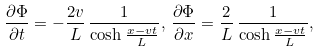Convert formula to latex. <formula><loc_0><loc_0><loc_500><loc_500>\frac { \partial \Phi } { \partial t } = - \frac { 2 v } { L } \, \frac { 1 } { \cosh { \frac { x - v t } { L } } } , \, \frac { \partial \Phi } { \partial x } = \frac { 2 } { L } \, \frac { 1 } { \cosh { \frac { x - v t } { L } } } ,</formula> 